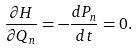<formula> <loc_0><loc_0><loc_500><loc_500>\frac { \partial H } { \partial Q _ { n } } = - \frac { d P _ { n } } { d t } = 0 .</formula> 